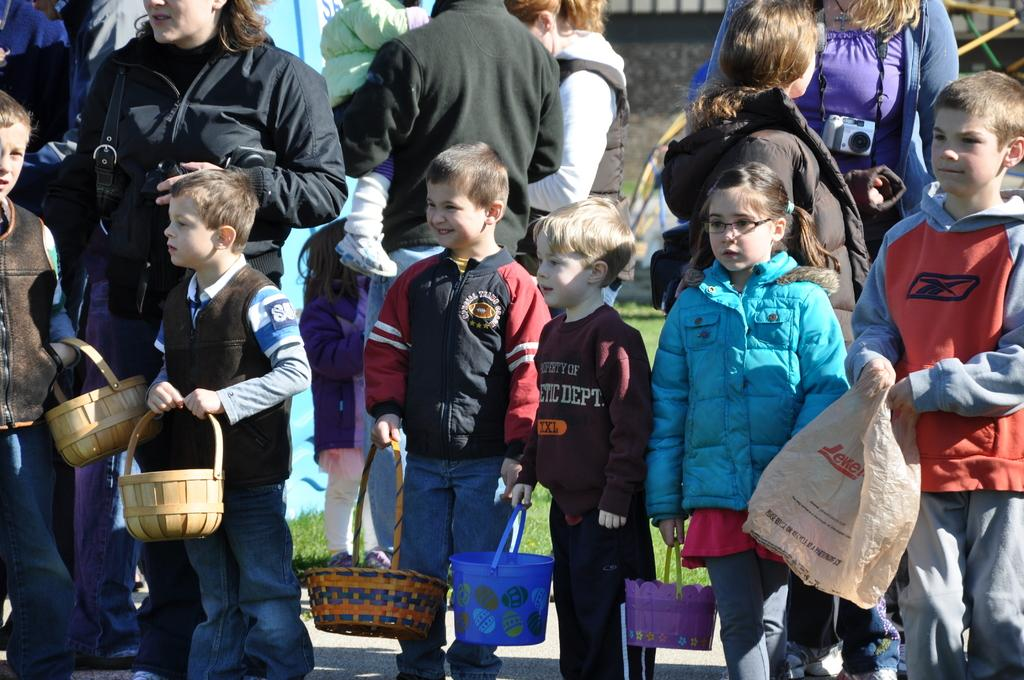Who is present in the image? There are people in the image, including kids. What are the kids doing in the image? The kids are standing on the ground, holding baskets and bags. What can be seen in the background of the image? There is grass visible in the background, along with other objects. What type of clouds can be seen in the image? There are no clouds visible in the image; it features people, kids, and objects against a background of grass and other objects. 